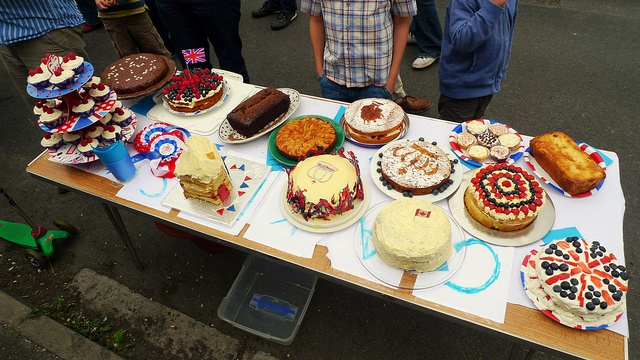Describe the objects in this image and their specific colors. I can see dining table in black, tan, and red tones, people in black, gray, darkgray, and brown tones, people in black, navy, darkblue, and blue tones, cake in black, beige, and gray tones, and people in black, brown, salmon, and darkblue tones in this image. 